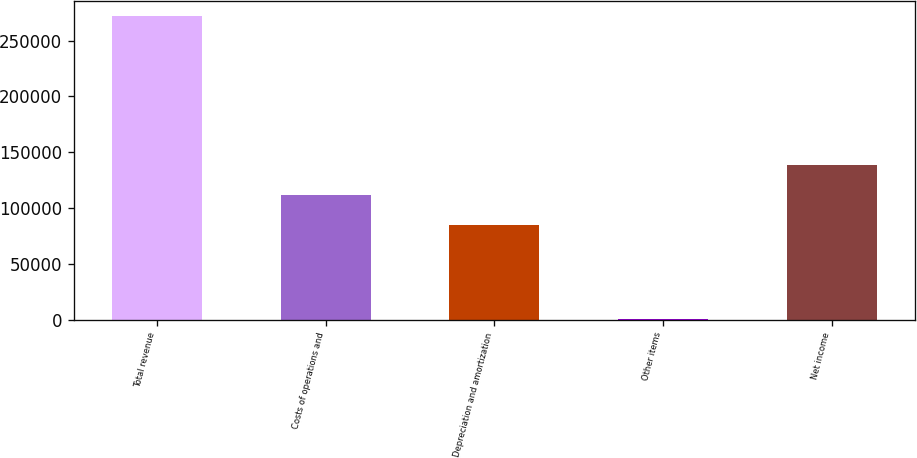Convert chart. <chart><loc_0><loc_0><loc_500><loc_500><bar_chart><fcel>Total revenue<fcel>Costs of operations and<fcel>Depreciation and amortization<fcel>Other items<fcel>Net income<nl><fcel>271655<fcel>111600<fcel>84504<fcel>698<fcel>138695<nl></chart> 